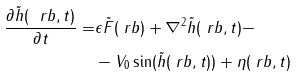Convert formula to latex. <formula><loc_0><loc_0><loc_500><loc_500>\frac { \partial \tilde { h } ( \ r b , t ) } { \partial t } = & \epsilon \tilde { F } ( \ r b ) + \nabla ^ { 2 } \tilde { h } ( \ r b , t ) - \\ & - V _ { 0 } \sin ( \tilde { h } ( \ r b , t ) ) + \eta ( \ r b , t )</formula> 